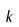Convert formula to latex. <formula><loc_0><loc_0><loc_500><loc_500>k</formula> 